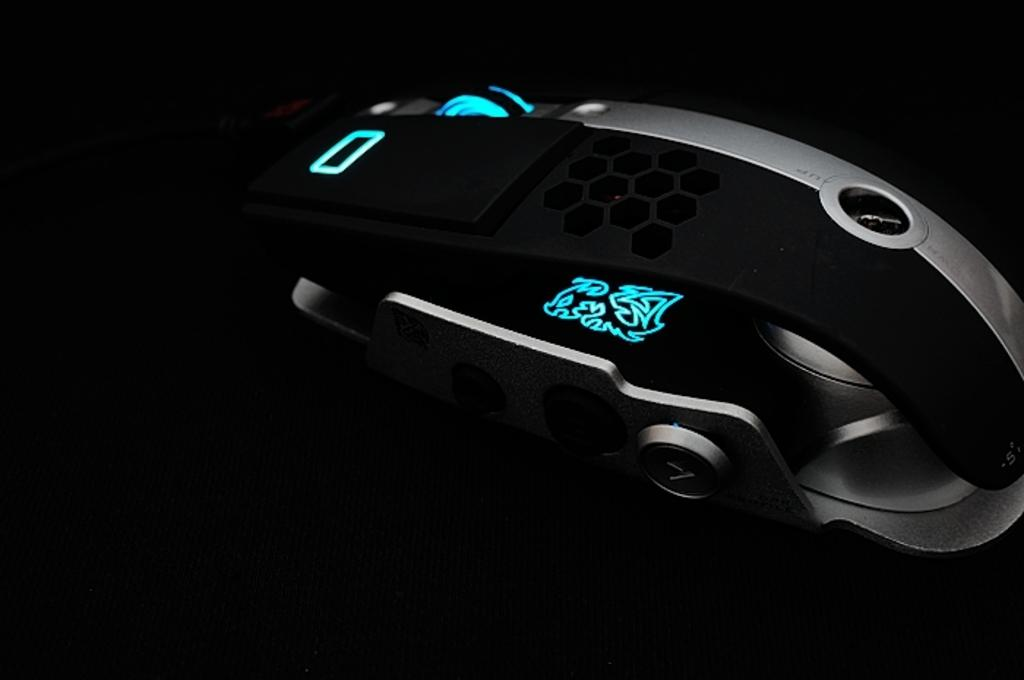What type of animal is present in the image? There is a mouse in the image. What type of lunch does the fireman bring to the mouse in the image? There is no fireman or lunch present in the image; it only features a mouse. 